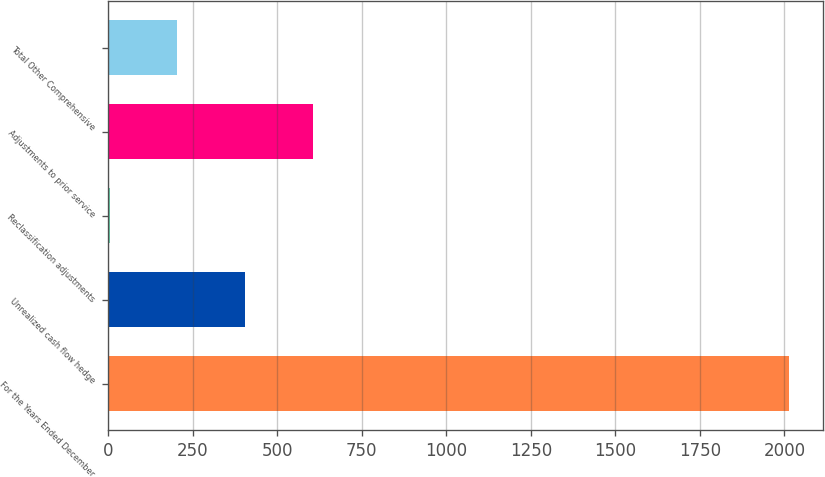Convert chart to OTSL. <chart><loc_0><loc_0><loc_500><loc_500><bar_chart><fcel>For the Years Ended December<fcel>Unrealized cash flow hedge<fcel>Reclassification adjustments<fcel>Adjustments to prior service<fcel>Total Other Comprehensive<nl><fcel>2013<fcel>406.12<fcel>4.4<fcel>606.98<fcel>205.26<nl></chart> 